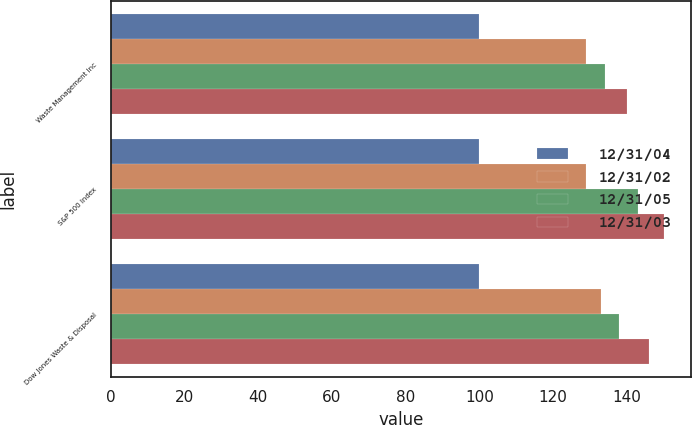Convert chart. <chart><loc_0><loc_0><loc_500><loc_500><stacked_bar_chart><ecel><fcel>Waste Management Inc<fcel>S&P 500 Index<fcel>Dow Jones Waste & Disposal<nl><fcel>12/31/04<fcel>100<fcel>100<fcel>100<nl><fcel>12/31/02<fcel>129<fcel>129<fcel>133<nl><fcel>12/31/05<fcel>134<fcel>143<fcel>138<nl><fcel>12/31/03<fcel>140<fcel>150<fcel>146<nl></chart> 